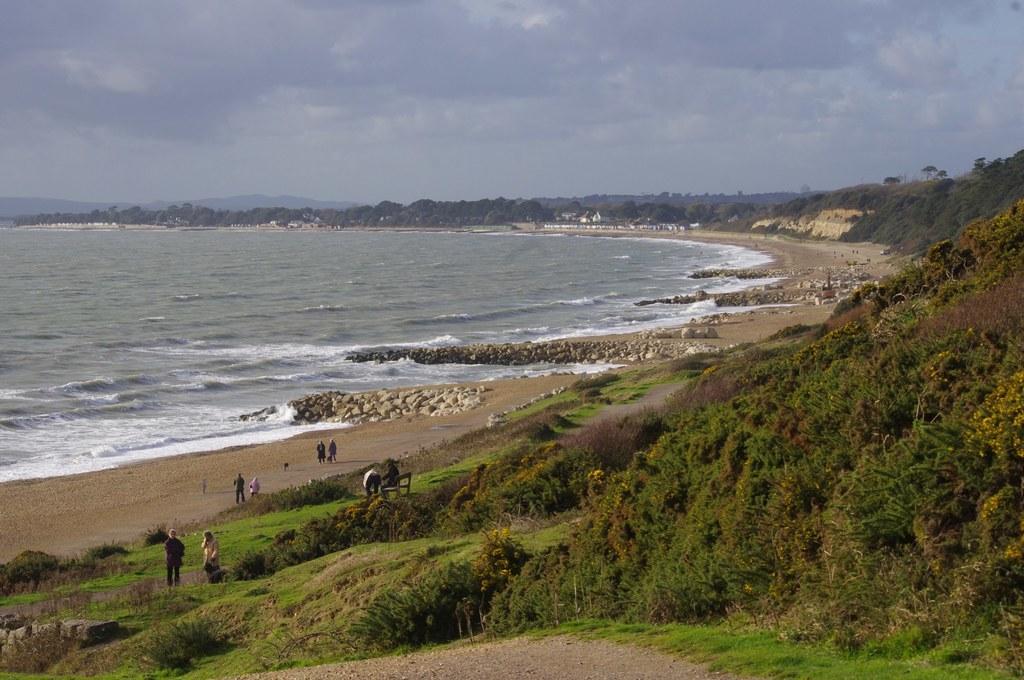Can you describe this image briefly? In this image we can see few plants, trees, people standing on the ground, stones, water on the left side and the sky with clouds on the top. 